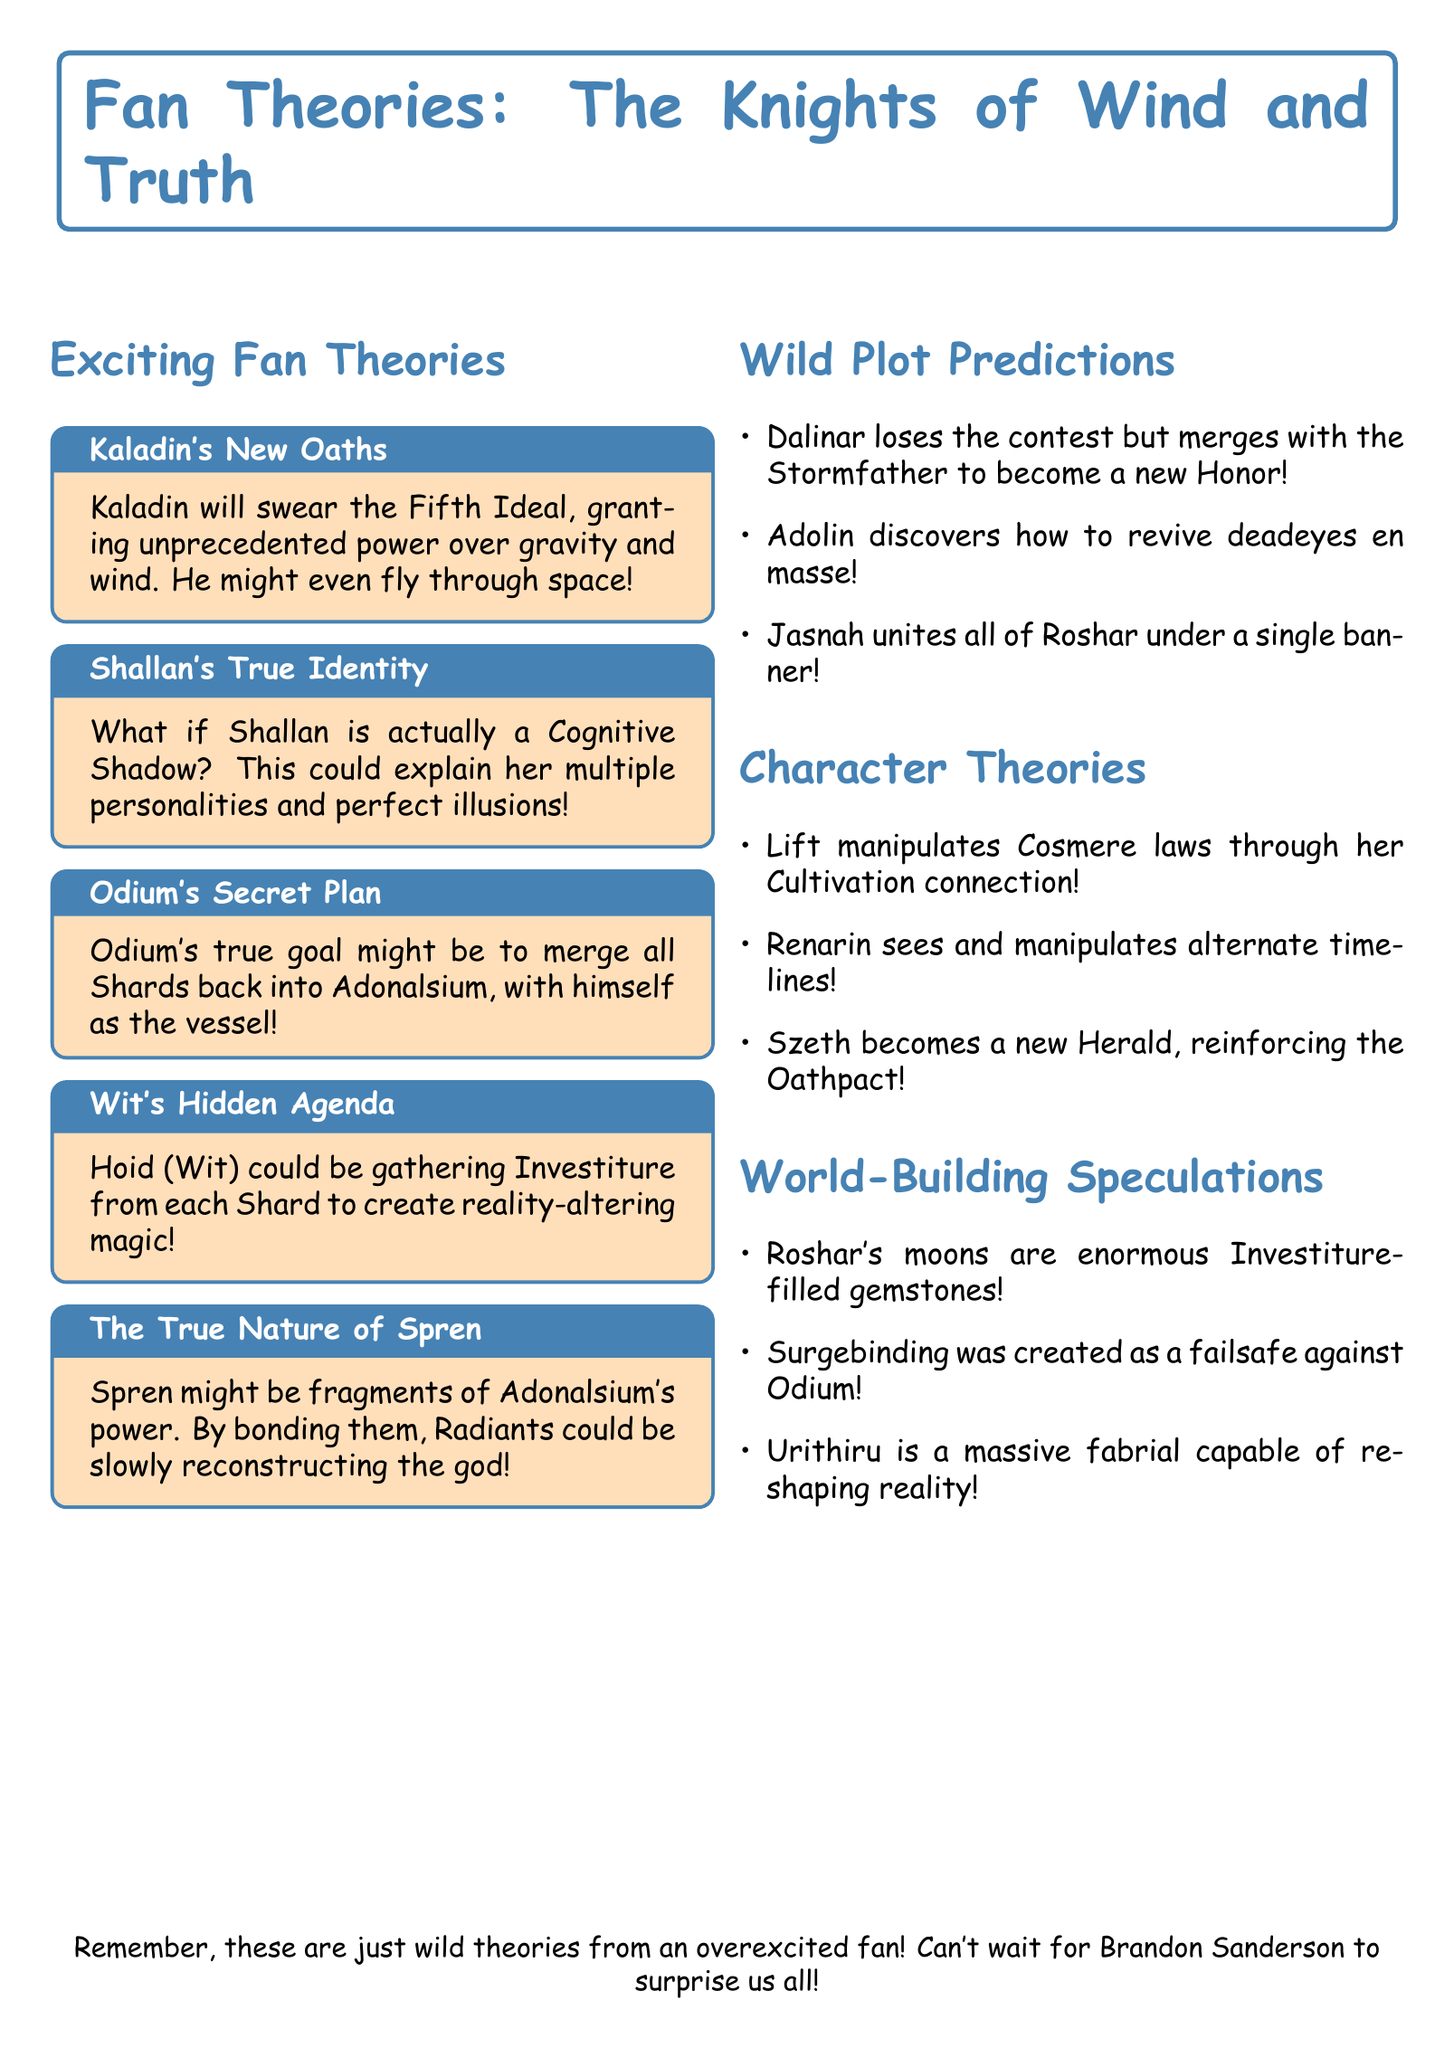what is the upcoming book title? The title of the upcoming book is stated in the document.
Answer: The Knights of Wind and Truth who is the author of the book series? The author of the book series is mentioned at the beginning of the document.
Answer: Brandon Sanderson how many character theories are presented? The number of character theories can be determined by counting the entries in the corresponding section of the document.
Answer: Three what is Kaladin's supposed new power? The description of Kaladin's theory explains the specific new power he might gain.
Answer: Power over gravity and wind what might Odium's true goal be? The document provides a specific theory about Odium's ultimate objective.
Answer: Merge all Shards back into Adonalsium who is theorized to become a new Herald? This question looks for the character mentioned in the character theories section who may take on this role.
Answer: Szeth what are Roshar's moons theorized to be? The document offers a specific theory regarding the nature of Roshar's moons.
Answer: Enormous gemstones containing vast amounts of Investiture how does Jasnah plan to influence Roshar? The speculation section describes Jasnah's intended action concerning the plot.
Answer: Unite all of Roshar under a single banner what is Wit's hidden agenda theorized to involve? The theory about Wit's intentions explains the kind of magic he might be pursuing.
Answer: Gathering Investiture to create reality-altering magic 